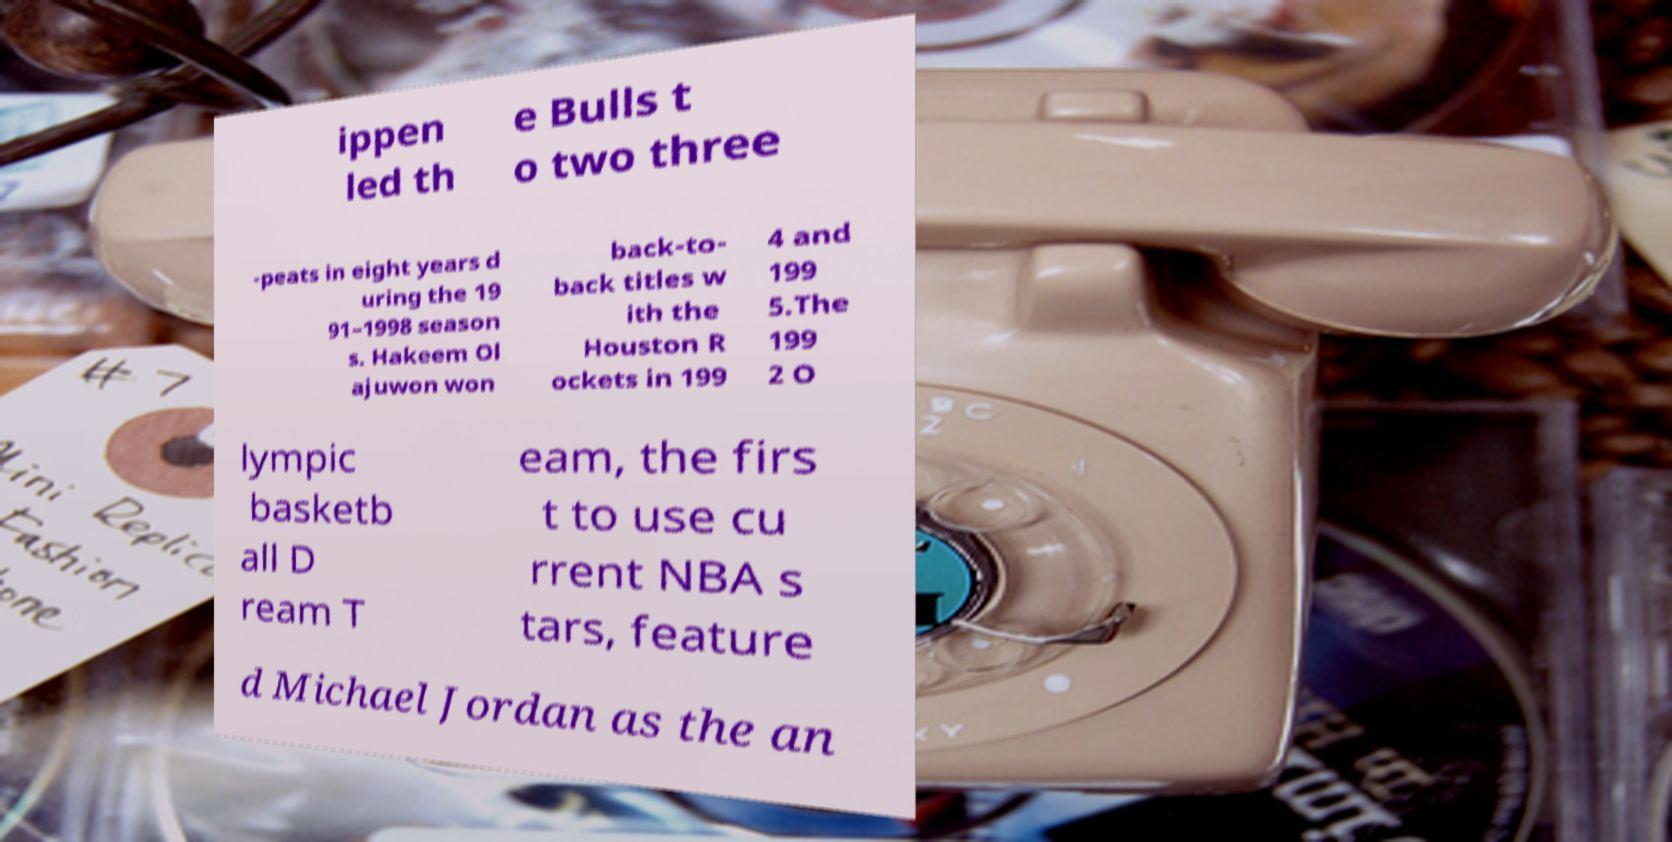Can you read and provide the text displayed in the image?This photo seems to have some interesting text. Can you extract and type it out for me? ippen led th e Bulls t o two three -peats in eight years d uring the 19 91–1998 season s. Hakeem Ol ajuwon won back-to- back titles w ith the Houston R ockets in 199 4 and 199 5.The 199 2 O lympic basketb all D ream T eam, the firs t to use cu rrent NBA s tars, feature d Michael Jordan as the an 